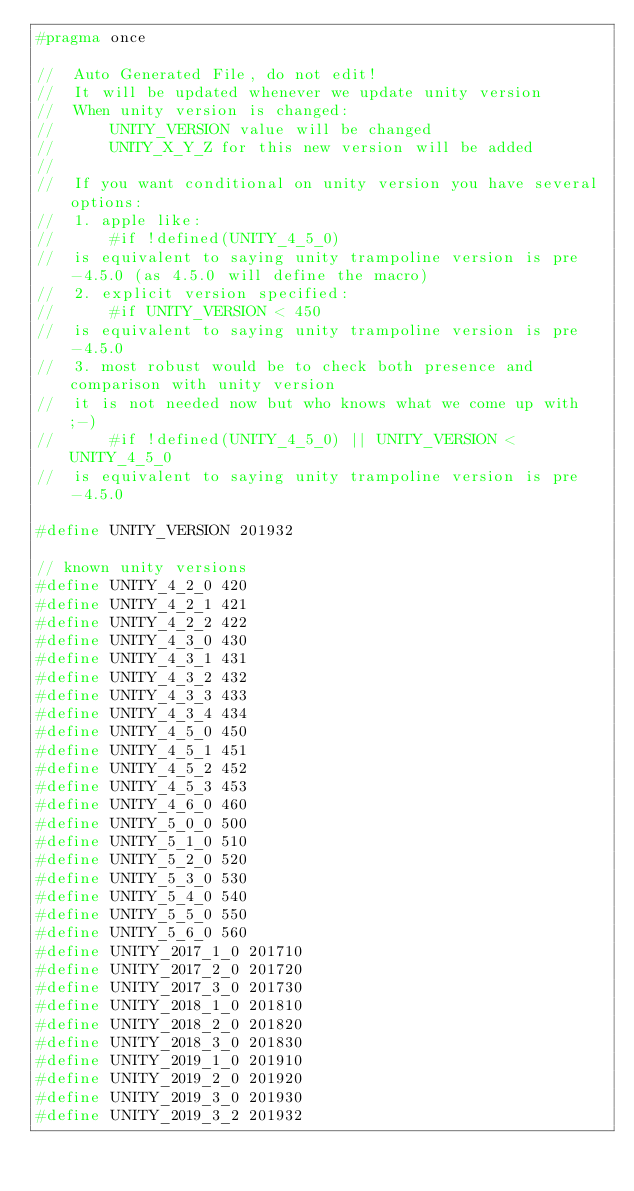<code> <loc_0><loc_0><loc_500><loc_500><_C_>#pragma once

//  Auto Generated File, do not edit!
//  It will be updated whenever we update unity version
//  When unity version is changed:
//      UNITY_VERSION value will be changed
//      UNITY_X_Y_Z for this new version will be added
//
//  If you want conditional on unity version you have several options:
//  1. apple like:
//      #if !defined(UNITY_4_5_0)
//  is equivalent to saying unity trampoline version is pre-4.5.0 (as 4.5.0 will define the macro)
//  2. explicit version specified:
//      #if UNITY_VERSION < 450
//  is equivalent to saying unity trampoline version is pre-4.5.0
//  3. most robust would be to check both presence and comparison with unity version
//  it is not needed now but who knows what we come up with ;-)
//      #if !defined(UNITY_4_5_0) || UNITY_VERSION < UNITY_4_5_0
//  is equivalent to saying unity trampoline version is pre-4.5.0

#define UNITY_VERSION 201932

// known unity versions
#define UNITY_4_2_0 420
#define UNITY_4_2_1 421
#define UNITY_4_2_2 422
#define UNITY_4_3_0 430
#define UNITY_4_3_1 431
#define UNITY_4_3_2 432
#define UNITY_4_3_3 433
#define UNITY_4_3_4 434
#define UNITY_4_5_0 450
#define UNITY_4_5_1 451
#define UNITY_4_5_2 452
#define UNITY_4_5_3 453
#define UNITY_4_6_0 460
#define UNITY_5_0_0 500
#define UNITY_5_1_0 510
#define UNITY_5_2_0 520
#define UNITY_5_3_0 530
#define UNITY_5_4_0 540
#define UNITY_5_5_0 550
#define UNITY_5_6_0 560
#define UNITY_2017_1_0 201710
#define UNITY_2017_2_0 201720
#define UNITY_2017_3_0 201730
#define UNITY_2018_1_0 201810
#define UNITY_2018_2_0 201820
#define UNITY_2018_3_0 201830
#define UNITY_2019_1_0 201910
#define UNITY_2019_2_0 201920
#define UNITY_2019_3_0 201930
#define UNITY_2019_3_2 201932
</code> 